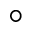<formula> <loc_0><loc_0><loc_500><loc_500>^ { \circ }</formula> 